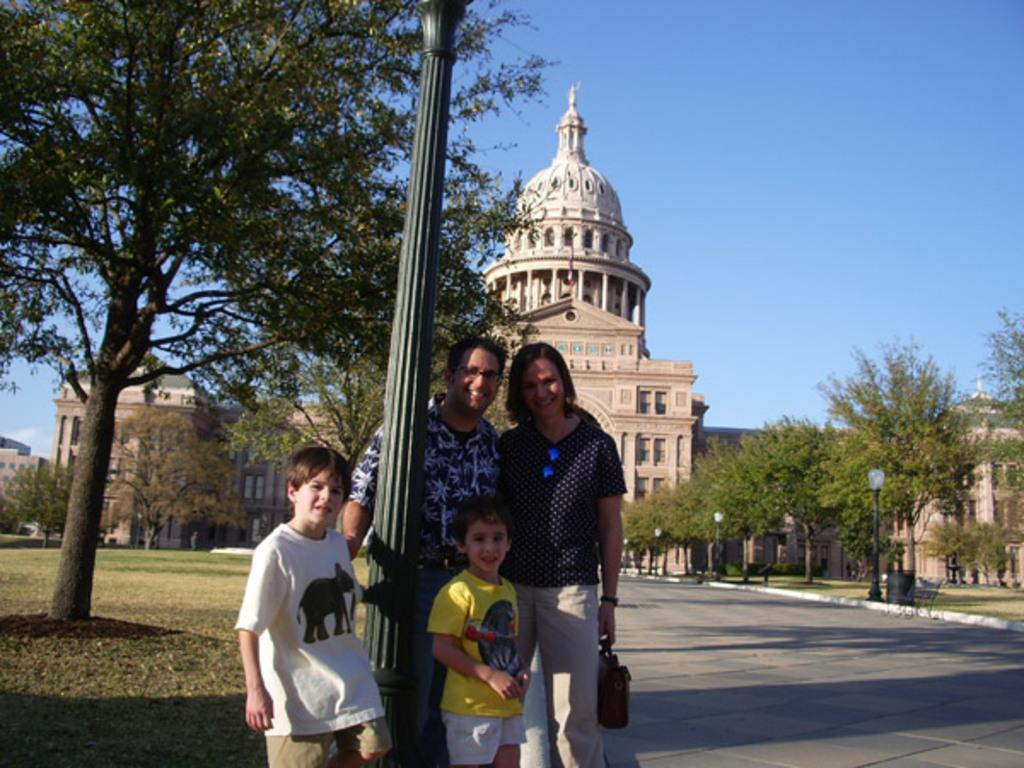Who is present in the image? There is a couple and two children in the image. What are the couple and children doing in the image? The couple and children are standing together. What is separating the couple and children in the image? There is a pole in between the couple and children. What can be seen in the background of the image? There are trees, at least one building, and the sky visible in the background of the image. What type of cable is being used by the children to play in the image? There is no cable present in the image; the children are standing with the couple. 